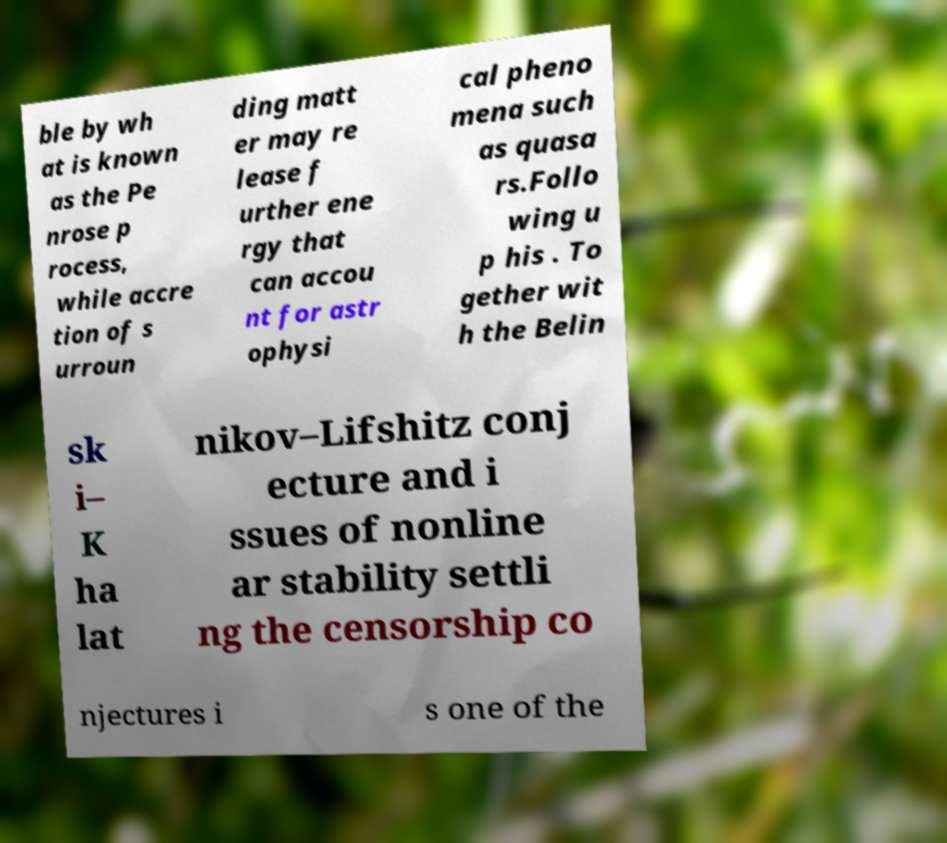Please read and relay the text visible in this image. What does it say? ble by wh at is known as the Pe nrose p rocess, while accre tion of s urroun ding matt er may re lease f urther ene rgy that can accou nt for astr ophysi cal pheno mena such as quasa rs.Follo wing u p his . To gether wit h the Belin sk i– K ha lat nikov–Lifshitz conj ecture and i ssues of nonline ar stability settli ng the censorship co njectures i s one of the 